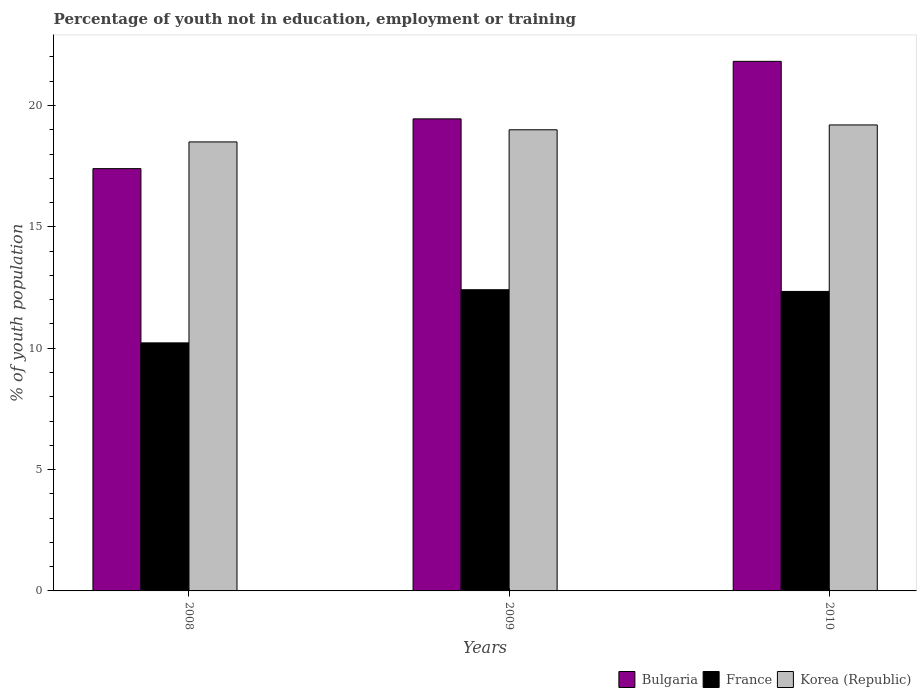How many groups of bars are there?
Ensure brevity in your answer.  3. Are the number of bars per tick equal to the number of legend labels?
Ensure brevity in your answer.  Yes. How many bars are there on the 1st tick from the right?
Offer a terse response. 3. Across all years, what is the maximum percentage of unemployed youth population in in Bulgaria?
Ensure brevity in your answer.  21.82. Across all years, what is the minimum percentage of unemployed youth population in in France?
Give a very brief answer. 10.22. What is the total percentage of unemployed youth population in in Korea (Republic) in the graph?
Your answer should be compact. 56.7. What is the difference between the percentage of unemployed youth population in in France in 2009 and that in 2010?
Give a very brief answer. 0.07. What is the average percentage of unemployed youth population in in France per year?
Give a very brief answer. 11.66. In the year 2010, what is the difference between the percentage of unemployed youth population in in France and percentage of unemployed youth population in in Korea (Republic)?
Offer a terse response. -6.86. What is the ratio of the percentage of unemployed youth population in in France in 2009 to that in 2010?
Provide a short and direct response. 1.01. Is the difference between the percentage of unemployed youth population in in France in 2008 and 2010 greater than the difference between the percentage of unemployed youth population in in Korea (Republic) in 2008 and 2010?
Your answer should be compact. No. What is the difference between the highest and the second highest percentage of unemployed youth population in in Bulgaria?
Give a very brief answer. 2.37. What is the difference between the highest and the lowest percentage of unemployed youth population in in France?
Provide a short and direct response. 2.19. In how many years, is the percentage of unemployed youth population in in France greater than the average percentage of unemployed youth population in in France taken over all years?
Your answer should be compact. 2. Is the sum of the percentage of unemployed youth population in in Bulgaria in 2008 and 2009 greater than the maximum percentage of unemployed youth population in in Korea (Republic) across all years?
Offer a terse response. Yes. What does the 2nd bar from the left in 2008 represents?
Make the answer very short. France. Is it the case that in every year, the sum of the percentage of unemployed youth population in in Bulgaria and percentage of unemployed youth population in in France is greater than the percentage of unemployed youth population in in Korea (Republic)?
Keep it short and to the point. Yes. How many bars are there?
Ensure brevity in your answer.  9. How many years are there in the graph?
Your answer should be very brief. 3. What is the difference between two consecutive major ticks on the Y-axis?
Provide a succinct answer. 5. Are the values on the major ticks of Y-axis written in scientific E-notation?
Provide a short and direct response. No. Does the graph contain grids?
Offer a very short reply. No. How many legend labels are there?
Keep it short and to the point. 3. How are the legend labels stacked?
Offer a terse response. Horizontal. What is the title of the graph?
Provide a succinct answer. Percentage of youth not in education, employment or training. Does "Tanzania" appear as one of the legend labels in the graph?
Ensure brevity in your answer.  No. What is the label or title of the X-axis?
Your answer should be very brief. Years. What is the label or title of the Y-axis?
Provide a succinct answer. % of youth population. What is the % of youth population of Bulgaria in 2008?
Ensure brevity in your answer.  17.4. What is the % of youth population in France in 2008?
Make the answer very short. 10.22. What is the % of youth population of Korea (Republic) in 2008?
Offer a very short reply. 18.5. What is the % of youth population in Bulgaria in 2009?
Give a very brief answer. 19.45. What is the % of youth population in France in 2009?
Provide a succinct answer. 12.41. What is the % of youth population in Korea (Republic) in 2009?
Your answer should be compact. 19. What is the % of youth population in Bulgaria in 2010?
Give a very brief answer. 21.82. What is the % of youth population in France in 2010?
Provide a short and direct response. 12.34. What is the % of youth population of Korea (Republic) in 2010?
Provide a succinct answer. 19.2. Across all years, what is the maximum % of youth population in Bulgaria?
Give a very brief answer. 21.82. Across all years, what is the maximum % of youth population in France?
Make the answer very short. 12.41. Across all years, what is the maximum % of youth population of Korea (Republic)?
Offer a terse response. 19.2. Across all years, what is the minimum % of youth population of Bulgaria?
Give a very brief answer. 17.4. Across all years, what is the minimum % of youth population in France?
Give a very brief answer. 10.22. What is the total % of youth population of Bulgaria in the graph?
Your answer should be very brief. 58.67. What is the total % of youth population in France in the graph?
Keep it short and to the point. 34.97. What is the total % of youth population of Korea (Republic) in the graph?
Your answer should be compact. 56.7. What is the difference between the % of youth population of Bulgaria in 2008 and that in 2009?
Provide a short and direct response. -2.05. What is the difference between the % of youth population of France in 2008 and that in 2009?
Give a very brief answer. -2.19. What is the difference between the % of youth population in Korea (Republic) in 2008 and that in 2009?
Offer a very short reply. -0.5. What is the difference between the % of youth population in Bulgaria in 2008 and that in 2010?
Offer a terse response. -4.42. What is the difference between the % of youth population of France in 2008 and that in 2010?
Give a very brief answer. -2.12. What is the difference between the % of youth population in Bulgaria in 2009 and that in 2010?
Keep it short and to the point. -2.37. What is the difference between the % of youth population of France in 2009 and that in 2010?
Your answer should be compact. 0.07. What is the difference between the % of youth population in Bulgaria in 2008 and the % of youth population in France in 2009?
Provide a succinct answer. 4.99. What is the difference between the % of youth population of France in 2008 and the % of youth population of Korea (Republic) in 2009?
Ensure brevity in your answer.  -8.78. What is the difference between the % of youth population in Bulgaria in 2008 and the % of youth population in France in 2010?
Make the answer very short. 5.06. What is the difference between the % of youth population in France in 2008 and the % of youth population in Korea (Republic) in 2010?
Your answer should be compact. -8.98. What is the difference between the % of youth population of Bulgaria in 2009 and the % of youth population of France in 2010?
Provide a succinct answer. 7.11. What is the difference between the % of youth population of Bulgaria in 2009 and the % of youth population of Korea (Republic) in 2010?
Your response must be concise. 0.25. What is the difference between the % of youth population in France in 2009 and the % of youth population in Korea (Republic) in 2010?
Make the answer very short. -6.79. What is the average % of youth population in Bulgaria per year?
Your response must be concise. 19.56. What is the average % of youth population in France per year?
Your response must be concise. 11.66. What is the average % of youth population in Korea (Republic) per year?
Make the answer very short. 18.9. In the year 2008, what is the difference between the % of youth population in Bulgaria and % of youth population in France?
Give a very brief answer. 7.18. In the year 2008, what is the difference between the % of youth population of Bulgaria and % of youth population of Korea (Republic)?
Give a very brief answer. -1.1. In the year 2008, what is the difference between the % of youth population in France and % of youth population in Korea (Republic)?
Give a very brief answer. -8.28. In the year 2009, what is the difference between the % of youth population of Bulgaria and % of youth population of France?
Provide a short and direct response. 7.04. In the year 2009, what is the difference between the % of youth population of Bulgaria and % of youth population of Korea (Republic)?
Your answer should be very brief. 0.45. In the year 2009, what is the difference between the % of youth population of France and % of youth population of Korea (Republic)?
Give a very brief answer. -6.59. In the year 2010, what is the difference between the % of youth population of Bulgaria and % of youth population of France?
Ensure brevity in your answer.  9.48. In the year 2010, what is the difference between the % of youth population of Bulgaria and % of youth population of Korea (Republic)?
Provide a short and direct response. 2.62. In the year 2010, what is the difference between the % of youth population of France and % of youth population of Korea (Republic)?
Provide a succinct answer. -6.86. What is the ratio of the % of youth population of Bulgaria in 2008 to that in 2009?
Your answer should be very brief. 0.89. What is the ratio of the % of youth population in France in 2008 to that in 2009?
Make the answer very short. 0.82. What is the ratio of the % of youth population in Korea (Republic) in 2008 to that in 2009?
Provide a succinct answer. 0.97. What is the ratio of the % of youth population of Bulgaria in 2008 to that in 2010?
Offer a terse response. 0.8. What is the ratio of the % of youth population in France in 2008 to that in 2010?
Make the answer very short. 0.83. What is the ratio of the % of youth population in Korea (Republic) in 2008 to that in 2010?
Keep it short and to the point. 0.96. What is the ratio of the % of youth population of Bulgaria in 2009 to that in 2010?
Your response must be concise. 0.89. What is the ratio of the % of youth population in France in 2009 to that in 2010?
Provide a succinct answer. 1.01. What is the difference between the highest and the second highest % of youth population in Bulgaria?
Your answer should be compact. 2.37. What is the difference between the highest and the second highest % of youth population of France?
Provide a short and direct response. 0.07. What is the difference between the highest and the lowest % of youth population in Bulgaria?
Your answer should be very brief. 4.42. What is the difference between the highest and the lowest % of youth population in France?
Provide a succinct answer. 2.19. 